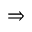<formula> <loc_0><loc_0><loc_500><loc_500>\Rightarrow</formula> 